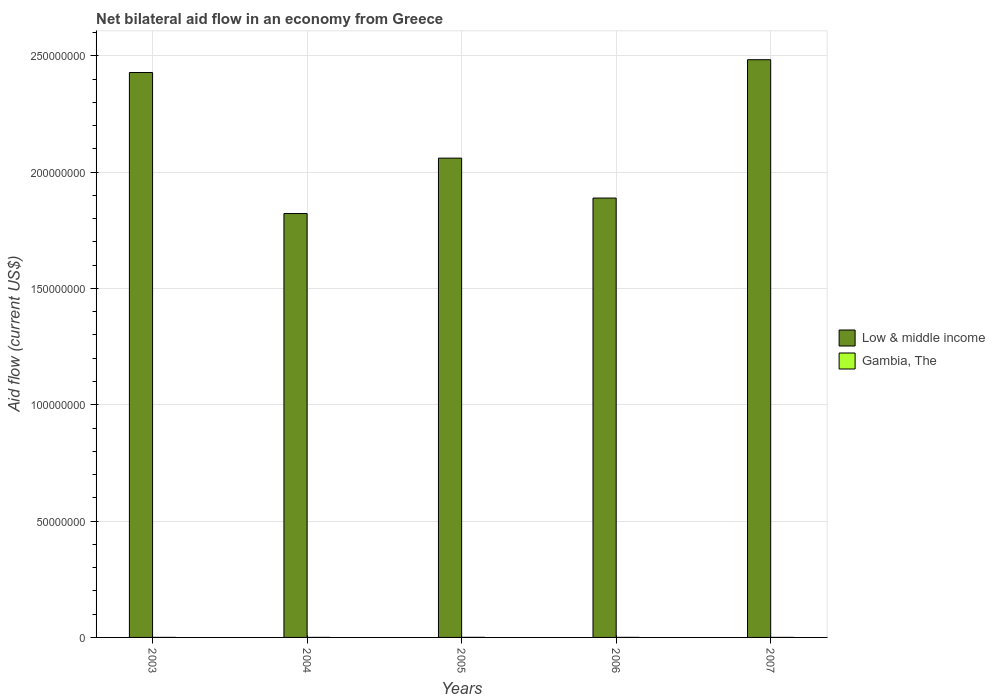How many groups of bars are there?
Your answer should be compact. 5. Are the number of bars on each tick of the X-axis equal?
Make the answer very short. Yes. How many bars are there on the 1st tick from the right?
Your response must be concise. 2. Across all years, what is the maximum net bilateral aid flow in Low & middle income?
Provide a short and direct response. 2.48e+08. In which year was the net bilateral aid flow in Gambia, The maximum?
Your answer should be very brief. 2005. In which year was the net bilateral aid flow in Gambia, The minimum?
Offer a terse response. 2003. What is the total net bilateral aid flow in Low & middle income in the graph?
Make the answer very short. 1.07e+09. What is the difference between the net bilateral aid flow in Gambia, The in 2006 and that in 2007?
Make the answer very short. 10000. What is the difference between the net bilateral aid flow in Low & middle income in 2003 and the net bilateral aid flow in Gambia, The in 2005?
Your answer should be very brief. 2.43e+08. What is the average net bilateral aid flow in Gambia, The per year?
Offer a very short reply. 1.60e+04. In the year 2003, what is the difference between the net bilateral aid flow in Low & middle income and net bilateral aid flow in Gambia, The?
Offer a very short reply. 2.43e+08. What is the ratio of the net bilateral aid flow in Gambia, The in 2004 to that in 2005?
Provide a succinct answer. 0.33. Is the net bilateral aid flow in Low & middle income in 2004 less than that in 2006?
Your answer should be very brief. Yes. What is the difference between the highest and the second highest net bilateral aid flow in Gambia, The?
Provide a succinct answer. 10000. What does the 2nd bar from the left in 2007 represents?
Give a very brief answer. Gambia, The. What does the 2nd bar from the right in 2004 represents?
Your answer should be compact. Low & middle income. Are all the bars in the graph horizontal?
Provide a short and direct response. No. Are the values on the major ticks of Y-axis written in scientific E-notation?
Give a very brief answer. No. How many legend labels are there?
Offer a terse response. 2. How are the legend labels stacked?
Your answer should be compact. Vertical. What is the title of the graph?
Make the answer very short. Net bilateral aid flow in an economy from Greece. Does "Croatia" appear as one of the legend labels in the graph?
Your answer should be very brief. No. What is the Aid flow (current US$) of Low & middle income in 2003?
Your response must be concise. 2.43e+08. What is the Aid flow (current US$) in Low & middle income in 2004?
Keep it short and to the point. 1.82e+08. What is the Aid flow (current US$) in Low & middle income in 2005?
Provide a succinct answer. 2.06e+08. What is the Aid flow (current US$) of Low & middle income in 2006?
Keep it short and to the point. 1.89e+08. What is the Aid flow (current US$) of Gambia, The in 2006?
Offer a very short reply. 2.00e+04. What is the Aid flow (current US$) in Low & middle income in 2007?
Ensure brevity in your answer.  2.48e+08. Across all years, what is the maximum Aid flow (current US$) of Low & middle income?
Your response must be concise. 2.48e+08. Across all years, what is the maximum Aid flow (current US$) of Gambia, The?
Your answer should be very brief. 3.00e+04. Across all years, what is the minimum Aid flow (current US$) of Low & middle income?
Provide a succinct answer. 1.82e+08. What is the total Aid flow (current US$) of Low & middle income in the graph?
Provide a succinct answer. 1.07e+09. What is the total Aid flow (current US$) of Gambia, The in the graph?
Your response must be concise. 8.00e+04. What is the difference between the Aid flow (current US$) in Low & middle income in 2003 and that in 2004?
Your answer should be very brief. 6.06e+07. What is the difference between the Aid flow (current US$) in Gambia, The in 2003 and that in 2004?
Provide a succinct answer. 0. What is the difference between the Aid flow (current US$) in Low & middle income in 2003 and that in 2005?
Provide a short and direct response. 3.68e+07. What is the difference between the Aid flow (current US$) in Low & middle income in 2003 and that in 2006?
Provide a succinct answer. 5.40e+07. What is the difference between the Aid flow (current US$) in Low & middle income in 2003 and that in 2007?
Your answer should be compact. -5.51e+06. What is the difference between the Aid flow (current US$) in Gambia, The in 2003 and that in 2007?
Make the answer very short. 0. What is the difference between the Aid flow (current US$) of Low & middle income in 2004 and that in 2005?
Your answer should be very brief. -2.38e+07. What is the difference between the Aid flow (current US$) in Gambia, The in 2004 and that in 2005?
Provide a short and direct response. -2.00e+04. What is the difference between the Aid flow (current US$) of Low & middle income in 2004 and that in 2006?
Your answer should be very brief. -6.66e+06. What is the difference between the Aid flow (current US$) of Low & middle income in 2004 and that in 2007?
Ensure brevity in your answer.  -6.61e+07. What is the difference between the Aid flow (current US$) in Low & middle income in 2005 and that in 2006?
Provide a short and direct response. 1.72e+07. What is the difference between the Aid flow (current US$) of Low & middle income in 2005 and that in 2007?
Your response must be concise. -4.23e+07. What is the difference between the Aid flow (current US$) of Low & middle income in 2006 and that in 2007?
Your answer should be very brief. -5.95e+07. What is the difference between the Aid flow (current US$) in Gambia, The in 2006 and that in 2007?
Provide a short and direct response. 10000. What is the difference between the Aid flow (current US$) of Low & middle income in 2003 and the Aid flow (current US$) of Gambia, The in 2004?
Offer a terse response. 2.43e+08. What is the difference between the Aid flow (current US$) in Low & middle income in 2003 and the Aid flow (current US$) in Gambia, The in 2005?
Provide a short and direct response. 2.43e+08. What is the difference between the Aid flow (current US$) in Low & middle income in 2003 and the Aid flow (current US$) in Gambia, The in 2006?
Keep it short and to the point. 2.43e+08. What is the difference between the Aid flow (current US$) of Low & middle income in 2003 and the Aid flow (current US$) of Gambia, The in 2007?
Offer a terse response. 2.43e+08. What is the difference between the Aid flow (current US$) of Low & middle income in 2004 and the Aid flow (current US$) of Gambia, The in 2005?
Provide a short and direct response. 1.82e+08. What is the difference between the Aid flow (current US$) in Low & middle income in 2004 and the Aid flow (current US$) in Gambia, The in 2006?
Your response must be concise. 1.82e+08. What is the difference between the Aid flow (current US$) in Low & middle income in 2004 and the Aid flow (current US$) in Gambia, The in 2007?
Your answer should be very brief. 1.82e+08. What is the difference between the Aid flow (current US$) in Low & middle income in 2005 and the Aid flow (current US$) in Gambia, The in 2006?
Provide a succinct answer. 2.06e+08. What is the difference between the Aid flow (current US$) in Low & middle income in 2005 and the Aid flow (current US$) in Gambia, The in 2007?
Your answer should be very brief. 2.06e+08. What is the difference between the Aid flow (current US$) of Low & middle income in 2006 and the Aid flow (current US$) of Gambia, The in 2007?
Provide a short and direct response. 1.89e+08. What is the average Aid flow (current US$) of Low & middle income per year?
Your answer should be very brief. 2.14e+08. What is the average Aid flow (current US$) of Gambia, The per year?
Keep it short and to the point. 1.60e+04. In the year 2003, what is the difference between the Aid flow (current US$) in Low & middle income and Aid flow (current US$) in Gambia, The?
Offer a terse response. 2.43e+08. In the year 2004, what is the difference between the Aid flow (current US$) of Low & middle income and Aid flow (current US$) of Gambia, The?
Give a very brief answer. 1.82e+08. In the year 2005, what is the difference between the Aid flow (current US$) in Low & middle income and Aid flow (current US$) in Gambia, The?
Ensure brevity in your answer.  2.06e+08. In the year 2006, what is the difference between the Aid flow (current US$) in Low & middle income and Aid flow (current US$) in Gambia, The?
Give a very brief answer. 1.89e+08. In the year 2007, what is the difference between the Aid flow (current US$) in Low & middle income and Aid flow (current US$) in Gambia, The?
Give a very brief answer. 2.48e+08. What is the ratio of the Aid flow (current US$) of Low & middle income in 2003 to that in 2004?
Your response must be concise. 1.33. What is the ratio of the Aid flow (current US$) in Gambia, The in 2003 to that in 2004?
Your answer should be compact. 1. What is the ratio of the Aid flow (current US$) in Low & middle income in 2003 to that in 2005?
Your answer should be compact. 1.18. What is the ratio of the Aid flow (current US$) in Low & middle income in 2003 to that in 2006?
Give a very brief answer. 1.29. What is the ratio of the Aid flow (current US$) of Gambia, The in 2003 to that in 2006?
Provide a short and direct response. 0.5. What is the ratio of the Aid flow (current US$) in Low & middle income in 2003 to that in 2007?
Keep it short and to the point. 0.98. What is the ratio of the Aid flow (current US$) of Gambia, The in 2003 to that in 2007?
Offer a terse response. 1. What is the ratio of the Aid flow (current US$) in Low & middle income in 2004 to that in 2005?
Your response must be concise. 0.88. What is the ratio of the Aid flow (current US$) in Gambia, The in 2004 to that in 2005?
Your response must be concise. 0.33. What is the ratio of the Aid flow (current US$) in Low & middle income in 2004 to that in 2006?
Offer a terse response. 0.96. What is the ratio of the Aid flow (current US$) in Low & middle income in 2004 to that in 2007?
Your answer should be compact. 0.73. What is the ratio of the Aid flow (current US$) in Gambia, The in 2005 to that in 2006?
Keep it short and to the point. 1.5. What is the ratio of the Aid flow (current US$) of Low & middle income in 2005 to that in 2007?
Your answer should be very brief. 0.83. What is the ratio of the Aid flow (current US$) of Gambia, The in 2005 to that in 2007?
Offer a terse response. 3. What is the ratio of the Aid flow (current US$) of Low & middle income in 2006 to that in 2007?
Provide a succinct answer. 0.76. What is the difference between the highest and the second highest Aid flow (current US$) of Low & middle income?
Offer a terse response. 5.51e+06. What is the difference between the highest and the lowest Aid flow (current US$) of Low & middle income?
Provide a short and direct response. 6.61e+07. 